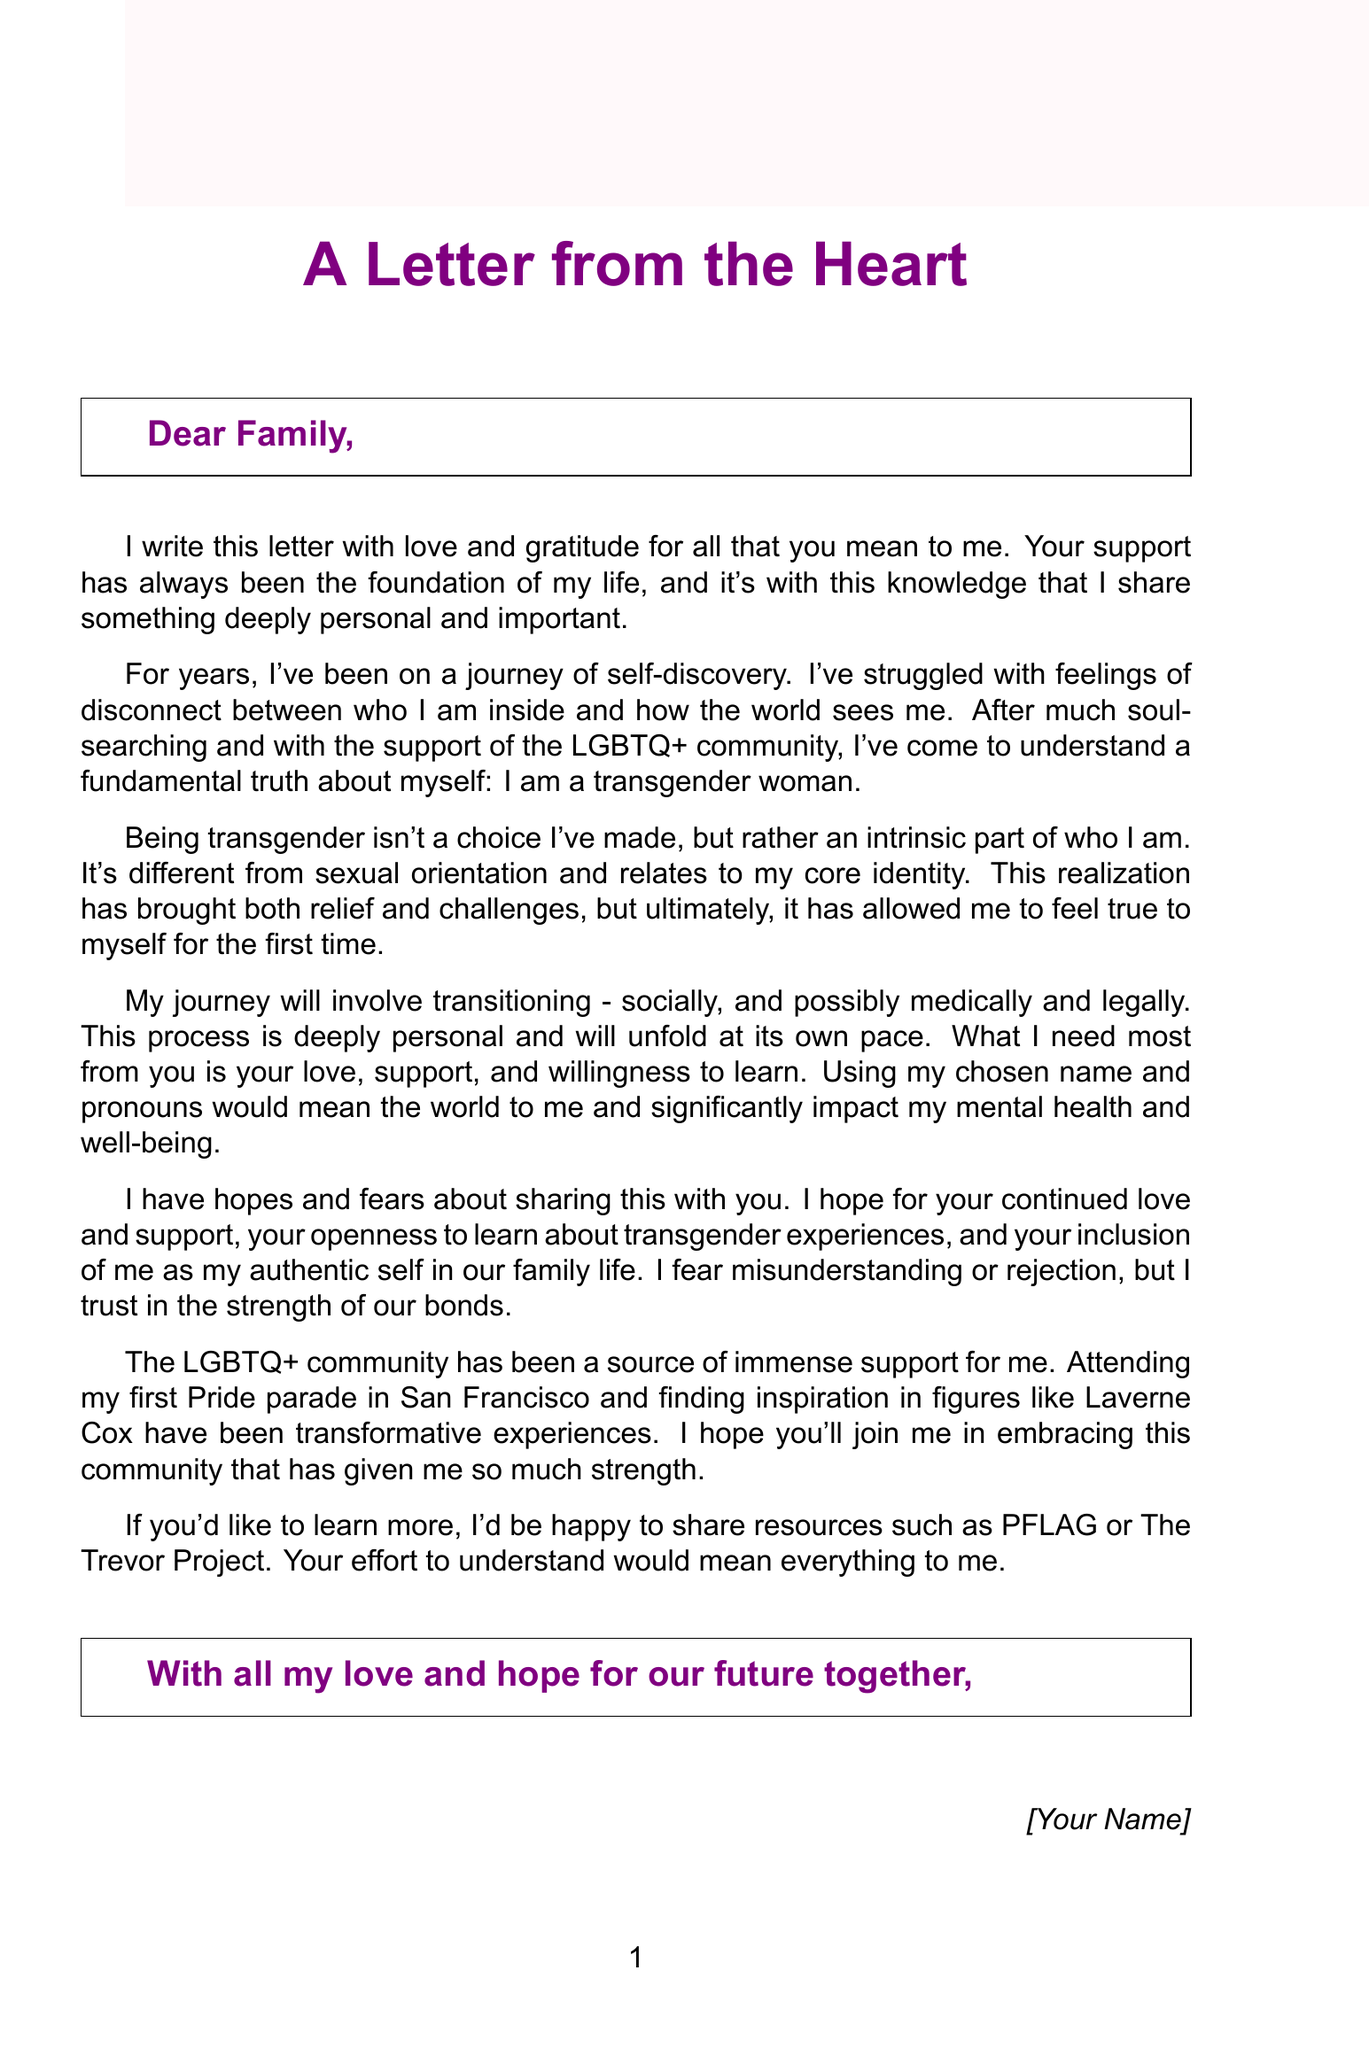What is the main purpose of the letter? The letter aims to express the author's journey of self-discovery and to communicate their identity as a transgender woman to their family, seeking love and acceptance.
Answer: To communicate identity Who is the author addressing in the letter? The author is directly writing to their family members, indicating a personal appeal for understanding and support.
Answer: Family What key aspect of their identity does the author explain? The author clarifies that being transgender is a fundamental aspect of who they are, not a choice, and differs from sexual orientation.
Answer: Being transgender Which LGBTQ+ figure mentioned has inspired the author? The author references public figures who have provided inspiration, specifically mentioning Laverne Cox.
Answer: Laverne Cox What is one of the author's hopes for their family? The author hopes for their family's continued love and support, with an emphasis on their willingness to learn about transgender experiences.
Answer: Continued love and support What resource does the author suggest for further learning? The author offers resources for their family to learn more about transgender experiences, specifically mentioning PFLAG and The Trevor Project.
Answer: PFLAG What type of transition does the author mention they will be undergoing? The author discusses plans for a social, medical, and legal transition, highlighting the personal nature of this process.
Answer: Transitioning What emotional expression does the author convey regarding potential rejection? The author expresses a fear of rejection or misunderstanding but maintains hope in the strength of familial bonds.
Answer: Fear of rejection How does the author close the letter? The author closes with a heartfelt affirmation of love and hope for their future together with their family.
Answer: With all my love and hope 